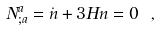Convert formula to latex. <formula><loc_0><loc_0><loc_500><loc_500>N ^ { a } _ { ; a } = \dot { n } + 3 H n = 0 \ ,</formula> 